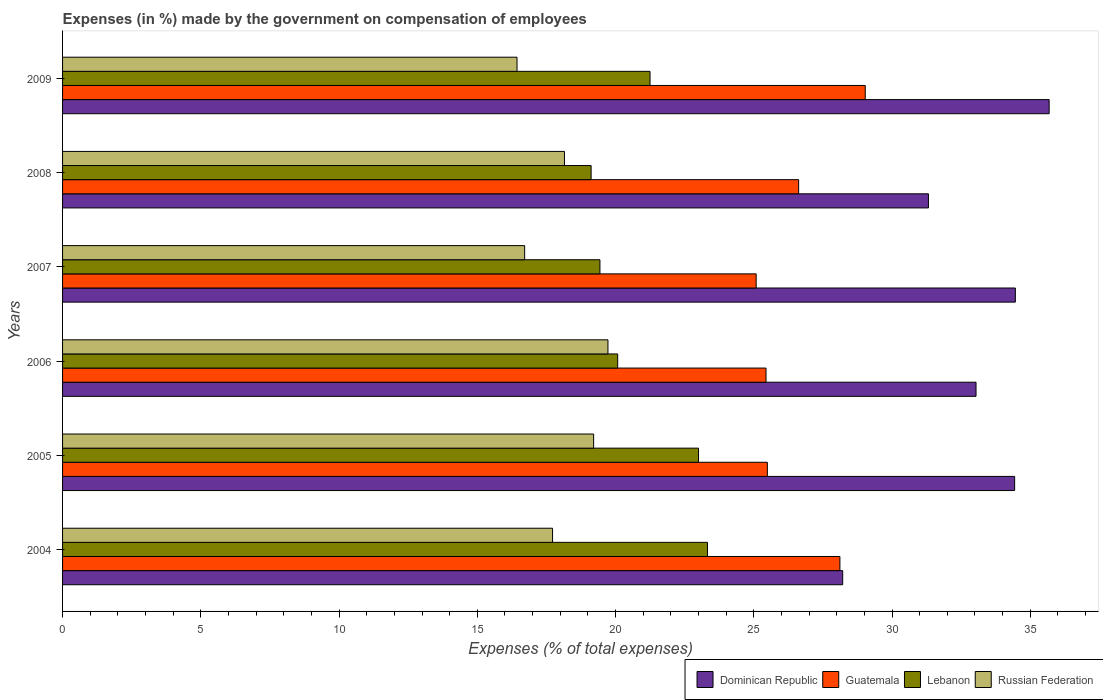Are the number of bars per tick equal to the number of legend labels?
Your answer should be very brief. Yes. What is the label of the 2nd group of bars from the top?
Provide a succinct answer. 2008. In how many cases, is the number of bars for a given year not equal to the number of legend labels?
Provide a short and direct response. 0. What is the percentage of expenses made by the government on compensation of employees in Dominican Republic in 2004?
Ensure brevity in your answer.  28.22. Across all years, what is the maximum percentage of expenses made by the government on compensation of employees in Guatemala?
Provide a succinct answer. 29.03. Across all years, what is the minimum percentage of expenses made by the government on compensation of employees in Dominican Republic?
Offer a very short reply. 28.22. What is the total percentage of expenses made by the government on compensation of employees in Dominican Republic in the graph?
Offer a terse response. 197.15. What is the difference between the percentage of expenses made by the government on compensation of employees in Dominican Republic in 2006 and that in 2008?
Ensure brevity in your answer.  1.72. What is the difference between the percentage of expenses made by the government on compensation of employees in Lebanon in 2006 and the percentage of expenses made by the government on compensation of employees in Guatemala in 2005?
Your response must be concise. -5.41. What is the average percentage of expenses made by the government on compensation of employees in Russian Federation per year?
Give a very brief answer. 17.99. In the year 2006, what is the difference between the percentage of expenses made by the government on compensation of employees in Russian Federation and percentage of expenses made by the government on compensation of employees in Guatemala?
Keep it short and to the point. -5.72. What is the ratio of the percentage of expenses made by the government on compensation of employees in Dominican Republic in 2004 to that in 2005?
Provide a short and direct response. 0.82. Is the difference between the percentage of expenses made by the government on compensation of employees in Russian Federation in 2004 and 2007 greater than the difference between the percentage of expenses made by the government on compensation of employees in Guatemala in 2004 and 2007?
Give a very brief answer. No. What is the difference between the highest and the second highest percentage of expenses made by the government on compensation of employees in Lebanon?
Your answer should be very brief. 0.32. What is the difference between the highest and the lowest percentage of expenses made by the government on compensation of employees in Dominican Republic?
Offer a very short reply. 7.47. In how many years, is the percentage of expenses made by the government on compensation of employees in Lebanon greater than the average percentage of expenses made by the government on compensation of employees in Lebanon taken over all years?
Provide a short and direct response. 3. Is it the case that in every year, the sum of the percentage of expenses made by the government on compensation of employees in Russian Federation and percentage of expenses made by the government on compensation of employees in Guatemala is greater than the sum of percentage of expenses made by the government on compensation of employees in Dominican Republic and percentage of expenses made by the government on compensation of employees in Lebanon?
Make the answer very short. No. What does the 2nd bar from the top in 2007 represents?
Provide a succinct answer. Lebanon. What does the 2nd bar from the bottom in 2009 represents?
Ensure brevity in your answer.  Guatemala. How many bars are there?
Keep it short and to the point. 24. Are all the bars in the graph horizontal?
Your answer should be compact. Yes. What is the difference between two consecutive major ticks on the X-axis?
Ensure brevity in your answer.  5. Are the values on the major ticks of X-axis written in scientific E-notation?
Your answer should be compact. No. Does the graph contain grids?
Give a very brief answer. No. What is the title of the graph?
Provide a short and direct response. Expenses (in %) made by the government on compensation of employees. Does "Andorra" appear as one of the legend labels in the graph?
Provide a succinct answer. No. What is the label or title of the X-axis?
Your answer should be compact. Expenses (% of total expenses). What is the label or title of the Y-axis?
Provide a succinct answer. Years. What is the Expenses (% of total expenses) in Dominican Republic in 2004?
Your answer should be very brief. 28.22. What is the Expenses (% of total expenses) in Guatemala in 2004?
Offer a very short reply. 28.12. What is the Expenses (% of total expenses) of Lebanon in 2004?
Provide a succinct answer. 23.33. What is the Expenses (% of total expenses) of Russian Federation in 2004?
Give a very brief answer. 17.72. What is the Expenses (% of total expenses) of Dominican Republic in 2005?
Provide a short and direct response. 34.43. What is the Expenses (% of total expenses) of Guatemala in 2005?
Give a very brief answer. 25.49. What is the Expenses (% of total expenses) in Lebanon in 2005?
Your answer should be compact. 23. What is the Expenses (% of total expenses) in Russian Federation in 2005?
Offer a terse response. 19.21. What is the Expenses (% of total expenses) in Dominican Republic in 2006?
Your response must be concise. 33.04. What is the Expenses (% of total expenses) of Guatemala in 2006?
Give a very brief answer. 25.44. What is the Expenses (% of total expenses) of Lebanon in 2006?
Provide a short and direct response. 20.08. What is the Expenses (% of total expenses) of Russian Federation in 2006?
Provide a succinct answer. 19.73. What is the Expenses (% of total expenses) in Dominican Republic in 2007?
Provide a succinct answer. 34.46. What is the Expenses (% of total expenses) of Guatemala in 2007?
Give a very brief answer. 25.09. What is the Expenses (% of total expenses) in Lebanon in 2007?
Your response must be concise. 19.44. What is the Expenses (% of total expenses) in Russian Federation in 2007?
Provide a succinct answer. 16.71. What is the Expenses (% of total expenses) of Dominican Republic in 2008?
Your answer should be compact. 31.32. What is the Expenses (% of total expenses) of Guatemala in 2008?
Offer a terse response. 26.62. What is the Expenses (% of total expenses) of Lebanon in 2008?
Make the answer very short. 19.12. What is the Expenses (% of total expenses) of Russian Federation in 2008?
Give a very brief answer. 18.15. What is the Expenses (% of total expenses) in Dominican Republic in 2009?
Make the answer very short. 35.68. What is the Expenses (% of total expenses) in Guatemala in 2009?
Your answer should be very brief. 29.03. What is the Expenses (% of total expenses) of Lebanon in 2009?
Offer a terse response. 21.25. What is the Expenses (% of total expenses) in Russian Federation in 2009?
Your answer should be compact. 16.44. Across all years, what is the maximum Expenses (% of total expenses) in Dominican Republic?
Your answer should be compact. 35.68. Across all years, what is the maximum Expenses (% of total expenses) of Guatemala?
Your answer should be compact. 29.03. Across all years, what is the maximum Expenses (% of total expenses) in Lebanon?
Offer a terse response. 23.33. Across all years, what is the maximum Expenses (% of total expenses) in Russian Federation?
Offer a terse response. 19.73. Across all years, what is the minimum Expenses (% of total expenses) in Dominican Republic?
Provide a succinct answer. 28.22. Across all years, what is the minimum Expenses (% of total expenses) of Guatemala?
Provide a short and direct response. 25.09. Across all years, what is the minimum Expenses (% of total expenses) in Lebanon?
Your answer should be compact. 19.12. Across all years, what is the minimum Expenses (% of total expenses) in Russian Federation?
Give a very brief answer. 16.44. What is the total Expenses (% of total expenses) in Dominican Republic in the graph?
Provide a succinct answer. 197.15. What is the total Expenses (% of total expenses) of Guatemala in the graph?
Provide a short and direct response. 159.79. What is the total Expenses (% of total expenses) of Lebanon in the graph?
Ensure brevity in your answer.  126.2. What is the total Expenses (% of total expenses) in Russian Federation in the graph?
Provide a short and direct response. 107.96. What is the difference between the Expenses (% of total expenses) in Dominican Republic in 2004 and that in 2005?
Provide a succinct answer. -6.22. What is the difference between the Expenses (% of total expenses) in Guatemala in 2004 and that in 2005?
Offer a terse response. 2.62. What is the difference between the Expenses (% of total expenses) of Lebanon in 2004 and that in 2005?
Your answer should be very brief. 0.32. What is the difference between the Expenses (% of total expenses) in Russian Federation in 2004 and that in 2005?
Make the answer very short. -1.49. What is the difference between the Expenses (% of total expenses) in Dominican Republic in 2004 and that in 2006?
Provide a succinct answer. -4.82. What is the difference between the Expenses (% of total expenses) of Guatemala in 2004 and that in 2006?
Offer a very short reply. 2.67. What is the difference between the Expenses (% of total expenses) of Lebanon in 2004 and that in 2006?
Give a very brief answer. 3.25. What is the difference between the Expenses (% of total expenses) in Russian Federation in 2004 and that in 2006?
Offer a terse response. -2. What is the difference between the Expenses (% of total expenses) of Dominican Republic in 2004 and that in 2007?
Keep it short and to the point. -6.25. What is the difference between the Expenses (% of total expenses) of Guatemala in 2004 and that in 2007?
Your answer should be very brief. 3.03. What is the difference between the Expenses (% of total expenses) in Lebanon in 2004 and that in 2007?
Ensure brevity in your answer.  3.89. What is the difference between the Expenses (% of total expenses) of Russian Federation in 2004 and that in 2007?
Make the answer very short. 1.01. What is the difference between the Expenses (% of total expenses) of Dominican Republic in 2004 and that in 2008?
Give a very brief answer. -3.1. What is the difference between the Expenses (% of total expenses) of Guatemala in 2004 and that in 2008?
Your response must be concise. 1.49. What is the difference between the Expenses (% of total expenses) in Lebanon in 2004 and that in 2008?
Offer a very short reply. 4.21. What is the difference between the Expenses (% of total expenses) of Russian Federation in 2004 and that in 2008?
Offer a terse response. -0.43. What is the difference between the Expenses (% of total expenses) in Dominican Republic in 2004 and that in 2009?
Make the answer very short. -7.47. What is the difference between the Expenses (% of total expenses) of Guatemala in 2004 and that in 2009?
Keep it short and to the point. -0.92. What is the difference between the Expenses (% of total expenses) in Lebanon in 2004 and that in 2009?
Provide a succinct answer. 2.08. What is the difference between the Expenses (% of total expenses) of Russian Federation in 2004 and that in 2009?
Ensure brevity in your answer.  1.29. What is the difference between the Expenses (% of total expenses) of Dominican Republic in 2005 and that in 2006?
Your answer should be very brief. 1.4. What is the difference between the Expenses (% of total expenses) of Guatemala in 2005 and that in 2006?
Your answer should be compact. 0.05. What is the difference between the Expenses (% of total expenses) of Lebanon in 2005 and that in 2006?
Keep it short and to the point. 2.92. What is the difference between the Expenses (% of total expenses) of Russian Federation in 2005 and that in 2006?
Your response must be concise. -0.52. What is the difference between the Expenses (% of total expenses) in Dominican Republic in 2005 and that in 2007?
Your response must be concise. -0.03. What is the difference between the Expenses (% of total expenses) of Guatemala in 2005 and that in 2007?
Your answer should be very brief. 0.41. What is the difference between the Expenses (% of total expenses) of Lebanon in 2005 and that in 2007?
Make the answer very short. 3.57. What is the difference between the Expenses (% of total expenses) in Russian Federation in 2005 and that in 2007?
Give a very brief answer. 2.49. What is the difference between the Expenses (% of total expenses) in Dominican Republic in 2005 and that in 2008?
Offer a terse response. 3.12. What is the difference between the Expenses (% of total expenses) in Guatemala in 2005 and that in 2008?
Your answer should be very brief. -1.13. What is the difference between the Expenses (% of total expenses) of Lebanon in 2005 and that in 2008?
Give a very brief answer. 3.88. What is the difference between the Expenses (% of total expenses) of Russian Federation in 2005 and that in 2008?
Your answer should be very brief. 1.05. What is the difference between the Expenses (% of total expenses) in Dominican Republic in 2005 and that in 2009?
Make the answer very short. -1.25. What is the difference between the Expenses (% of total expenses) in Guatemala in 2005 and that in 2009?
Make the answer very short. -3.54. What is the difference between the Expenses (% of total expenses) in Lebanon in 2005 and that in 2009?
Offer a terse response. 1.75. What is the difference between the Expenses (% of total expenses) in Russian Federation in 2005 and that in 2009?
Your answer should be very brief. 2.77. What is the difference between the Expenses (% of total expenses) of Dominican Republic in 2006 and that in 2007?
Keep it short and to the point. -1.42. What is the difference between the Expenses (% of total expenses) in Guatemala in 2006 and that in 2007?
Keep it short and to the point. 0.36. What is the difference between the Expenses (% of total expenses) in Lebanon in 2006 and that in 2007?
Ensure brevity in your answer.  0.64. What is the difference between the Expenses (% of total expenses) in Russian Federation in 2006 and that in 2007?
Ensure brevity in your answer.  3.01. What is the difference between the Expenses (% of total expenses) in Dominican Republic in 2006 and that in 2008?
Offer a very short reply. 1.72. What is the difference between the Expenses (% of total expenses) in Guatemala in 2006 and that in 2008?
Offer a very short reply. -1.18. What is the difference between the Expenses (% of total expenses) in Russian Federation in 2006 and that in 2008?
Your answer should be compact. 1.57. What is the difference between the Expenses (% of total expenses) of Dominican Republic in 2006 and that in 2009?
Give a very brief answer. -2.65. What is the difference between the Expenses (% of total expenses) in Guatemala in 2006 and that in 2009?
Your answer should be very brief. -3.59. What is the difference between the Expenses (% of total expenses) in Lebanon in 2006 and that in 2009?
Your answer should be very brief. -1.17. What is the difference between the Expenses (% of total expenses) of Russian Federation in 2006 and that in 2009?
Offer a very short reply. 3.29. What is the difference between the Expenses (% of total expenses) of Dominican Republic in 2007 and that in 2008?
Provide a short and direct response. 3.14. What is the difference between the Expenses (% of total expenses) of Guatemala in 2007 and that in 2008?
Your answer should be very brief. -1.54. What is the difference between the Expenses (% of total expenses) in Lebanon in 2007 and that in 2008?
Your answer should be compact. 0.32. What is the difference between the Expenses (% of total expenses) of Russian Federation in 2007 and that in 2008?
Make the answer very short. -1.44. What is the difference between the Expenses (% of total expenses) of Dominican Republic in 2007 and that in 2009?
Ensure brevity in your answer.  -1.22. What is the difference between the Expenses (% of total expenses) of Guatemala in 2007 and that in 2009?
Offer a terse response. -3.95. What is the difference between the Expenses (% of total expenses) in Lebanon in 2007 and that in 2009?
Provide a succinct answer. -1.81. What is the difference between the Expenses (% of total expenses) of Russian Federation in 2007 and that in 2009?
Provide a short and direct response. 0.28. What is the difference between the Expenses (% of total expenses) in Dominican Republic in 2008 and that in 2009?
Make the answer very short. -4.37. What is the difference between the Expenses (% of total expenses) in Guatemala in 2008 and that in 2009?
Make the answer very short. -2.41. What is the difference between the Expenses (% of total expenses) of Lebanon in 2008 and that in 2009?
Provide a short and direct response. -2.13. What is the difference between the Expenses (% of total expenses) in Russian Federation in 2008 and that in 2009?
Make the answer very short. 1.72. What is the difference between the Expenses (% of total expenses) in Dominican Republic in 2004 and the Expenses (% of total expenses) in Guatemala in 2005?
Your answer should be compact. 2.72. What is the difference between the Expenses (% of total expenses) of Dominican Republic in 2004 and the Expenses (% of total expenses) of Lebanon in 2005?
Keep it short and to the point. 5.21. What is the difference between the Expenses (% of total expenses) of Dominican Republic in 2004 and the Expenses (% of total expenses) of Russian Federation in 2005?
Give a very brief answer. 9.01. What is the difference between the Expenses (% of total expenses) of Guatemala in 2004 and the Expenses (% of total expenses) of Lebanon in 2005?
Keep it short and to the point. 5.11. What is the difference between the Expenses (% of total expenses) in Guatemala in 2004 and the Expenses (% of total expenses) in Russian Federation in 2005?
Offer a very short reply. 8.91. What is the difference between the Expenses (% of total expenses) in Lebanon in 2004 and the Expenses (% of total expenses) in Russian Federation in 2005?
Keep it short and to the point. 4.12. What is the difference between the Expenses (% of total expenses) in Dominican Republic in 2004 and the Expenses (% of total expenses) in Guatemala in 2006?
Provide a short and direct response. 2.77. What is the difference between the Expenses (% of total expenses) in Dominican Republic in 2004 and the Expenses (% of total expenses) in Lebanon in 2006?
Offer a terse response. 8.14. What is the difference between the Expenses (% of total expenses) of Dominican Republic in 2004 and the Expenses (% of total expenses) of Russian Federation in 2006?
Provide a succinct answer. 8.49. What is the difference between the Expenses (% of total expenses) of Guatemala in 2004 and the Expenses (% of total expenses) of Lebanon in 2006?
Your answer should be very brief. 8.04. What is the difference between the Expenses (% of total expenses) of Guatemala in 2004 and the Expenses (% of total expenses) of Russian Federation in 2006?
Make the answer very short. 8.39. What is the difference between the Expenses (% of total expenses) of Lebanon in 2004 and the Expenses (% of total expenses) of Russian Federation in 2006?
Your response must be concise. 3.6. What is the difference between the Expenses (% of total expenses) in Dominican Republic in 2004 and the Expenses (% of total expenses) in Guatemala in 2007?
Ensure brevity in your answer.  3.13. What is the difference between the Expenses (% of total expenses) of Dominican Republic in 2004 and the Expenses (% of total expenses) of Lebanon in 2007?
Your response must be concise. 8.78. What is the difference between the Expenses (% of total expenses) in Dominican Republic in 2004 and the Expenses (% of total expenses) in Russian Federation in 2007?
Your answer should be compact. 11.5. What is the difference between the Expenses (% of total expenses) of Guatemala in 2004 and the Expenses (% of total expenses) of Lebanon in 2007?
Make the answer very short. 8.68. What is the difference between the Expenses (% of total expenses) in Guatemala in 2004 and the Expenses (% of total expenses) in Russian Federation in 2007?
Your answer should be compact. 11.4. What is the difference between the Expenses (% of total expenses) of Lebanon in 2004 and the Expenses (% of total expenses) of Russian Federation in 2007?
Keep it short and to the point. 6.61. What is the difference between the Expenses (% of total expenses) of Dominican Republic in 2004 and the Expenses (% of total expenses) of Guatemala in 2008?
Provide a succinct answer. 1.59. What is the difference between the Expenses (% of total expenses) of Dominican Republic in 2004 and the Expenses (% of total expenses) of Lebanon in 2008?
Offer a very short reply. 9.1. What is the difference between the Expenses (% of total expenses) in Dominican Republic in 2004 and the Expenses (% of total expenses) in Russian Federation in 2008?
Ensure brevity in your answer.  10.06. What is the difference between the Expenses (% of total expenses) of Guatemala in 2004 and the Expenses (% of total expenses) of Lebanon in 2008?
Your answer should be compact. 9. What is the difference between the Expenses (% of total expenses) in Guatemala in 2004 and the Expenses (% of total expenses) in Russian Federation in 2008?
Your answer should be very brief. 9.96. What is the difference between the Expenses (% of total expenses) of Lebanon in 2004 and the Expenses (% of total expenses) of Russian Federation in 2008?
Offer a very short reply. 5.17. What is the difference between the Expenses (% of total expenses) in Dominican Republic in 2004 and the Expenses (% of total expenses) in Guatemala in 2009?
Make the answer very short. -0.82. What is the difference between the Expenses (% of total expenses) of Dominican Republic in 2004 and the Expenses (% of total expenses) of Lebanon in 2009?
Offer a very short reply. 6.97. What is the difference between the Expenses (% of total expenses) in Dominican Republic in 2004 and the Expenses (% of total expenses) in Russian Federation in 2009?
Your answer should be compact. 11.78. What is the difference between the Expenses (% of total expenses) in Guatemala in 2004 and the Expenses (% of total expenses) in Lebanon in 2009?
Your answer should be compact. 6.87. What is the difference between the Expenses (% of total expenses) of Guatemala in 2004 and the Expenses (% of total expenses) of Russian Federation in 2009?
Offer a terse response. 11.68. What is the difference between the Expenses (% of total expenses) of Lebanon in 2004 and the Expenses (% of total expenses) of Russian Federation in 2009?
Your response must be concise. 6.89. What is the difference between the Expenses (% of total expenses) of Dominican Republic in 2005 and the Expenses (% of total expenses) of Guatemala in 2006?
Ensure brevity in your answer.  8.99. What is the difference between the Expenses (% of total expenses) of Dominican Republic in 2005 and the Expenses (% of total expenses) of Lebanon in 2006?
Provide a short and direct response. 14.36. What is the difference between the Expenses (% of total expenses) of Dominican Republic in 2005 and the Expenses (% of total expenses) of Russian Federation in 2006?
Your answer should be very brief. 14.71. What is the difference between the Expenses (% of total expenses) in Guatemala in 2005 and the Expenses (% of total expenses) in Lebanon in 2006?
Ensure brevity in your answer.  5.41. What is the difference between the Expenses (% of total expenses) of Guatemala in 2005 and the Expenses (% of total expenses) of Russian Federation in 2006?
Make the answer very short. 5.77. What is the difference between the Expenses (% of total expenses) in Lebanon in 2005 and the Expenses (% of total expenses) in Russian Federation in 2006?
Give a very brief answer. 3.28. What is the difference between the Expenses (% of total expenses) of Dominican Republic in 2005 and the Expenses (% of total expenses) of Guatemala in 2007?
Offer a very short reply. 9.35. What is the difference between the Expenses (% of total expenses) of Dominican Republic in 2005 and the Expenses (% of total expenses) of Lebanon in 2007?
Keep it short and to the point. 15. What is the difference between the Expenses (% of total expenses) of Dominican Republic in 2005 and the Expenses (% of total expenses) of Russian Federation in 2007?
Keep it short and to the point. 17.72. What is the difference between the Expenses (% of total expenses) of Guatemala in 2005 and the Expenses (% of total expenses) of Lebanon in 2007?
Ensure brevity in your answer.  6.06. What is the difference between the Expenses (% of total expenses) in Guatemala in 2005 and the Expenses (% of total expenses) in Russian Federation in 2007?
Give a very brief answer. 8.78. What is the difference between the Expenses (% of total expenses) in Lebanon in 2005 and the Expenses (% of total expenses) in Russian Federation in 2007?
Ensure brevity in your answer.  6.29. What is the difference between the Expenses (% of total expenses) in Dominican Republic in 2005 and the Expenses (% of total expenses) in Guatemala in 2008?
Ensure brevity in your answer.  7.81. What is the difference between the Expenses (% of total expenses) in Dominican Republic in 2005 and the Expenses (% of total expenses) in Lebanon in 2008?
Your answer should be very brief. 15.32. What is the difference between the Expenses (% of total expenses) in Dominican Republic in 2005 and the Expenses (% of total expenses) in Russian Federation in 2008?
Provide a short and direct response. 16.28. What is the difference between the Expenses (% of total expenses) in Guatemala in 2005 and the Expenses (% of total expenses) in Lebanon in 2008?
Your response must be concise. 6.37. What is the difference between the Expenses (% of total expenses) in Guatemala in 2005 and the Expenses (% of total expenses) in Russian Federation in 2008?
Your answer should be very brief. 7.34. What is the difference between the Expenses (% of total expenses) in Lebanon in 2005 and the Expenses (% of total expenses) in Russian Federation in 2008?
Offer a very short reply. 4.85. What is the difference between the Expenses (% of total expenses) of Dominican Republic in 2005 and the Expenses (% of total expenses) of Guatemala in 2009?
Offer a very short reply. 5.4. What is the difference between the Expenses (% of total expenses) in Dominican Republic in 2005 and the Expenses (% of total expenses) in Lebanon in 2009?
Your response must be concise. 13.19. What is the difference between the Expenses (% of total expenses) of Dominican Republic in 2005 and the Expenses (% of total expenses) of Russian Federation in 2009?
Give a very brief answer. 18. What is the difference between the Expenses (% of total expenses) in Guatemala in 2005 and the Expenses (% of total expenses) in Lebanon in 2009?
Give a very brief answer. 4.24. What is the difference between the Expenses (% of total expenses) in Guatemala in 2005 and the Expenses (% of total expenses) in Russian Federation in 2009?
Give a very brief answer. 9.05. What is the difference between the Expenses (% of total expenses) of Lebanon in 2005 and the Expenses (% of total expenses) of Russian Federation in 2009?
Keep it short and to the point. 6.56. What is the difference between the Expenses (% of total expenses) of Dominican Republic in 2006 and the Expenses (% of total expenses) of Guatemala in 2007?
Ensure brevity in your answer.  7.95. What is the difference between the Expenses (% of total expenses) of Dominican Republic in 2006 and the Expenses (% of total expenses) of Lebanon in 2007?
Your answer should be compact. 13.6. What is the difference between the Expenses (% of total expenses) in Dominican Republic in 2006 and the Expenses (% of total expenses) in Russian Federation in 2007?
Give a very brief answer. 16.33. What is the difference between the Expenses (% of total expenses) of Guatemala in 2006 and the Expenses (% of total expenses) of Lebanon in 2007?
Offer a very short reply. 6.01. What is the difference between the Expenses (% of total expenses) of Guatemala in 2006 and the Expenses (% of total expenses) of Russian Federation in 2007?
Offer a terse response. 8.73. What is the difference between the Expenses (% of total expenses) of Lebanon in 2006 and the Expenses (% of total expenses) of Russian Federation in 2007?
Offer a terse response. 3.36. What is the difference between the Expenses (% of total expenses) of Dominican Republic in 2006 and the Expenses (% of total expenses) of Guatemala in 2008?
Offer a terse response. 6.42. What is the difference between the Expenses (% of total expenses) in Dominican Republic in 2006 and the Expenses (% of total expenses) in Lebanon in 2008?
Offer a terse response. 13.92. What is the difference between the Expenses (% of total expenses) in Dominican Republic in 2006 and the Expenses (% of total expenses) in Russian Federation in 2008?
Make the answer very short. 14.89. What is the difference between the Expenses (% of total expenses) of Guatemala in 2006 and the Expenses (% of total expenses) of Lebanon in 2008?
Your response must be concise. 6.33. What is the difference between the Expenses (% of total expenses) in Guatemala in 2006 and the Expenses (% of total expenses) in Russian Federation in 2008?
Provide a succinct answer. 7.29. What is the difference between the Expenses (% of total expenses) in Lebanon in 2006 and the Expenses (% of total expenses) in Russian Federation in 2008?
Your answer should be compact. 1.92. What is the difference between the Expenses (% of total expenses) in Dominican Republic in 2006 and the Expenses (% of total expenses) in Guatemala in 2009?
Give a very brief answer. 4.01. What is the difference between the Expenses (% of total expenses) of Dominican Republic in 2006 and the Expenses (% of total expenses) of Lebanon in 2009?
Offer a terse response. 11.79. What is the difference between the Expenses (% of total expenses) in Dominican Republic in 2006 and the Expenses (% of total expenses) in Russian Federation in 2009?
Your answer should be compact. 16.6. What is the difference between the Expenses (% of total expenses) in Guatemala in 2006 and the Expenses (% of total expenses) in Lebanon in 2009?
Ensure brevity in your answer.  4.2. What is the difference between the Expenses (% of total expenses) of Guatemala in 2006 and the Expenses (% of total expenses) of Russian Federation in 2009?
Ensure brevity in your answer.  9.01. What is the difference between the Expenses (% of total expenses) in Lebanon in 2006 and the Expenses (% of total expenses) in Russian Federation in 2009?
Provide a succinct answer. 3.64. What is the difference between the Expenses (% of total expenses) of Dominican Republic in 2007 and the Expenses (% of total expenses) of Guatemala in 2008?
Your response must be concise. 7.84. What is the difference between the Expenses (% of total expenses) of Dominican Republic in 2007 and the Expenses (% of total expenses) of Lebanon in 2008?
Your answer should be very brief. 15.34. What is the difference between the Expenses (% of total expenses) of Dominican Republic in 2007 and the Expenses (% of total expenses) of Russian Federation in 2008?
Provide a succinct answer. 16.31. What is the difference between the Expenses (% of total expenses) of Guatemala in 2007 and the Expenses (% of total expenses) of Lebanon in 2008?
Give a very brief answer. 5.97. What is the difference between the Expenses (% of total expenses) of Guatemala in 2007 and the Expenses (% of total expenses) of Russian Federation in 2008?
Make the answer very short. 6.93. What is the difference between the Expenses (% of total expenses) in Lebanon in 2007 and the Expenses (% of total expenses) in Russian Federation in 2008?
Offer a very short reply. 1.28. What is the difference between the Expenses (% of total expenses) of Dominican Republic in 2007 and the Expenses (% of total expenses) of Guatemala in 2009?
Keep it short and to the point. 5.43. What is the difference between the Expenses (% of total expenses) in Dominican Republic in 2007 and the Expenses (% of total expenses) in Lebanon in 2009?
Your answer should be compact. 13.21. What is the difference between the Expenses (% of total expenses) of Dominican Republic in 2007 and the Expenses (% of total expenses) of Russian Federation in 2009?
Your response must be concise. 18.02. What is the difference between the Expenses (% of total expenses) of Guatemala in 2007 and the Expenses (% of total expenses) of Lebanon in 2009?
Your answer should be very brief. 3.84. What is the difference between the Expenses (% of total expenses) in Guatemala in 2007 and the Expenses (% of total expenses) in Russian Federation in 2009?
Your response must be concise. 8.65. What is the difference between the Expenses (% of total expenses) in Lebanon in 2007 and the Expenses (% of total expenses) in Russian Federation in 2009?
Ensure brevity in your answer.  3. What is the difference between the Expenses (% of total expenses) in Dominican Republic in 2008 and the Expenses (% of total expenses) in Guatemala in 2009?
Offer a very short reply. 2.28. What is the difference between the Expenses (% of total expenses) of Dominican Republic in 2008 and the Expenses (% of total expenses) of Lebanon in 2009?
Provide a succinct answer. 10.07. What is the difference between the Expenses (% of total expenses) in Dominican Republic in 2008 and the Expenses (% of total expenses) in Russian Federation in 2009?
Your answer should be very brief. 14.88. What is the difference between the Expenses (% of total expenses) of Guatemala in 2008 and the Expenses (% of total expenses) of Lebanon in 2009?
Your response must be concise. 5.38. What is the difference between the Expenses (% of total expenses) of Guatemala in 2008 and the Expenses (% of total expenses) of Russian Federation in 2009?
Provide a succinct answer. 10.19. What is the difference between the Expenses (% of total expenses) in Lebanon in 2008 and the Expenses (% of total expenses) in Russian Federation in 2009?
Your answer should be very brief. 2.68. What is the average Expenses (% of total expenses) of Dominican Republic per year?
Offer a terse response. 32.86. What is the average Expenses (% of total expenses) in Guatemala per year?
Provide a succinct answer. 26.63. What is the average Expenses (% of total expenses) of Lebanon per year?
Give a very brief answer. 21.03. What is the average Expenses (% of total expenses) in Russian Federation per year?
Offer a very short reply. 17.99. In the year 2004, what is the difference between the Expenses (% of total expenses) of Dominican Republic and Expenses (% of total expenses) of Guatemala?
Your response must be concise. 0.1. In the year 2004, what is the difference between the Expenses (% of total expenses) of Dominican Republic and Expenses (% of total expenses) of Lebanon?
Your answer should be compact. 4.89. In the year 2004, what is the difference between the Expenses (% of total expenses) in Dominican Republic and Expenses (% of total expenses) in Russian Federation?
Ensure brevity in your answer.  10.49. In the year 2004, what is the difference between the Expenses (% of total expenses) of Guatemala and Expenses (% of total expenses) of Lebanon?
Provide a succinct answer. 4.79. In the year 2004, what is the difference between the Expenses (% of total expenses) of Guatemala and Expenses (% of total expenses) of Russian Federation?
Your answer should be very brief. 10.39. In the year 2004, what is the difference between the Expenses (% of total expenses) of Lebanon and Expenses (% of total expenses) of Russian Federation?
Provide a succinct answer. 5.6. In the year 2005, what is the difference between the Expenses (% of total expenses) in Dominican Republic and Expenses (% of total expenses) in Guatemala?
Offer a terse response. 8.94. In the year 2005, what is the difference between the Expenses (% of total expenses) in Dominican Republic and Expenses (% of total expenses) in Lebanon?
Make the answer very short. 11.43. In the year 2005, what is the difference between the Expenses (% of total expenses) in Dominican Republic and Expenses (% of total expenses) in Russian Federation?
Your answer should be very brief. 15.23. In the year 2005, what is the difference between the Expenses (% of total expenses) in Guatemala and Expenses (% of total expenses) in Lebanon?
Offer a very short reply. 2.49. In the year 2005, what is the difference between the Expenses (% of total expenses) in Guatemala and Expenses (% of total expenses) in Russian Federation?
Your response must be concise. 6.28. In the year 2005, what is the difference between the Expenses (% of total expenses) in Lebanon and Expenses (% of total expenses) in Russian Federation?
Ensure brevity in your answer.  3.79. In the year 2006, what is the difference between the Expenses (% of total expenses) in Dominican Republic and Expenses (% of total expenses) in Guatemala?
Give a very brief answer. 7.6. In the year 2006, what is the difference between the Expenses (% of total expenses) of Dominican Republic and Expenses (% of total expenses) of Lebanon?
Ensure brevity in your answer.  12.96. In the year 2006, what is the difference between the Expenses (% of total expenses) of Dominican Republic and Expenses (% of total expenses) of Russian Federation?
Provide a short and direct response. 13.31. In the year 2006, what is the difference between the Expenses (% of total expenses) of Guatemala and Expenses (% of total expenses) of Lebanon?
Provide a succinct answer. 5.37. In the year 2006, what is the difference between the Expenses (% of total expenses) in Guatemala and Expenses (% of total expenses) in Russian Federation?
Keep it short and to the point. 5.72. In the year 2006, what is the difference between the Expenses (% of total expenses) in Lebanon and Expenses (% of total expenses) in Russian Federation?
Your answer should be compact. 0.35. In the year 2007, what is the difference between the Expenses (% of total expenses) in Dominican Republic and Expenses (% of total expenses) in Guatemala?
Offer a very short reply. 9.38. In the year 2007, what is the difference between the Expenses (% of total expenses) in Dominican Republic and Expenses (% of total expenses) in Lebanon?
Your response must be concise. 15.03. In the year 2007, what is the difference between the Expenses (% of total expenses) of Dominican Republic and Expenses (% of total expenses) of Russian Federation?
Provide a short and direct response. 17.75. In the year 2007, what is the difference between the Expenses (% of total expenses) in Guatemala and Expenses (% of total expenses) in Lebanon?
Your answer should be very brief. 5.65. In the year 2007, what is the difference between the Expenses (% of total expenses) in Guatemala and Expenses (% of total expenses) in Russian Federation?
Ensure brevity in your answer.  8.37. In the year 2007, what is the difference between the Expenses (% of total expenses) of Lebanon and Expenses (% of total expenses) of Russian Federation?
Your response must be concise. 2.72. In the year 2008, what is the difference between the Expenses (% of total expenses) in Dominican Republic and Expenses (% of total expenses) in Guatemala?
Give a very brief answer. 4.69. In the year 2008, what is the difference between the Expenses (% of total expenses) of Dominican Republic and Expenses (% of total expenses) of Lebanon?
Your answer should be very brief. 12.2. In the year 2008, what is the difference between the Expenses (% of total expenses) in Dominican Republic and Expenses (% of total expenses) in Russian Federation?
Make the answer very short. 13.16. In the year 2008, what is the difference between the Expenses (% of total expenses) of Guatemala and Expenses (% of total expenses) of Lebanon?
Give a very brief answer. 7.51. In the year 2008, what is the difference between the Expenses (% of total expenses) of Guatemala and Expenses (% of total expenses) of Russian Federation?
Offer a very short reply. 8.47. In the year 2008, what is the difference between the Expenses (% of total expenses) in Lebanon and Expenses (% of total expenses) in Russian Federation?
Offer a terse response. 0.96. In the year 2009, what is the difference between the Expenses (% of total expenses) of Dominican Republic and Expenses (% of total expenses) of Guatemala?
Keep it short and to the point. 6.65. In the year 2009, what is the difference between the Expenses (% of total expenses) of Dominican Republic and Expenses (% of total expenses) of Lebanon?
Provide a succinct answer. 14.44. In the year 2009, what is the difference between the Expenses (% of total expenses) in Dominican Republic and Expenses (% of total expenses) in Russian Federation?
Your answer should be compact. 19.25. In the year 2009, what is the difference between the Expenses (% of total expenses) in Guatemala and Expenses (% of total expenses) in Lebanon?
Provide a succinct answer. 7.78. In the year 2009, what is the difference between the Expenses (% of total expenses) of Guatemala and Expenses (% of total expenses) of Russian Federation?
Your answer should be compact. 12.6. In the year 2009, what is the difference between the Expenses (% of total expenses) in Lebanon and Expenses (% of total expenses) in Russian Federation?
Make the answer very short. 4.81. What is the ratio of the Expenses (% of total expenses) in Dominican Republic in 2004 to that in 2005?
Your answer should be compact. 0.82. What is the ratio of the Expenses (% of total expenses) of Guatemala in 2004 to that in 2005?
Give a very brief answer. 1.1. What is the ratio of the Expenses (% of total expenses) in Lebanon in 2004 to that in 2005?
Your answer should be compact. 1.01. What is the ratio of the Expenses (% of total expenses) in Russian Federation in 2004 to that in 2005?
Keep it short and to the point. 0.92. What is the ratio of the Expenses (% of total expenses) in Dominican Republic in 2004 to that in 2006?
Your answer should be compact. 0.85. What is the ratio of the Expenses (% of total expenses) in Guatemala in 2004 to that in 2006?
Offer a terse response. 1.1. What is the ratio of the Expenses (% of total expenses) of Lebanon in 2004 to that in 2006?
Provide a short and direct response. 1.16. What is the ratio of the Expenses (% of total expenses) of Russian Federation in 2004 to that in 2006?
Give a very brief answer. 0.9. What is the ratio of the Expenses (% of total expenses) in Dominican Republic in 2004 to that in 2007?
Keep it short and to the point. 0.82. What is the ratio of the Expenses (% of total expenses) in Guatemala in 2004 to that in 2007?
Your answer should be compact. 1.12. What is the ratio of the Expenses (% of total expenses) of Lebanon in 2004 to that in 2007?
Provide a succinct answer. 1.2. What is the ratio of the Expenses (% of total expenses) of Russian Federation in 2004 to that in 2007?
Your response must be concise. 1.06. What is the ratio of the Expenses (% of total expenses) of Dominican Republic in 2004 to that in 2008?
Keep it short and to the point. 0.9. What is the ratio of the Expenses (% of total expenses) in Guatemala in 2004 to that in 2008?
Your answer should be compact. 1.06. What is the ratio of the Expenses (% of total expenses) in Lebanon in 2004 to that in 2008?
Ensure brevity in your answer.  1.22. What is the ratio of the Expenses (% of total expenses) of Russian Federation in 2004 to that in 2008?
Offer a very short reply. 0.98. What is the ratio of the Expenses (% of total expenses) in Dominican Republic in 2004 to that in 2009?
Your response must be concise. 0.79. What is the ratio of the Expenses (% of total expenses) of Guatemala in 2004 to that in 2009?
Provide a succinct answer. 0.97. What is the ratio of the Expenses (% of total expenses) of Lebanon in 2004 to that in 2009?
Make the answer very short. 1.1. What is the ratio of the Expenses (% of total expenses) in Russian Federation in 2004 to that in 2009?
Provide a succinct answer. 1.08. What is the ratio of the Expenses (% of total expenses) in Dominican Republic in 2005 to that in 2006?
Give a very brief answer. 1.04. What is the ratio of the Expenses (% of total expenses) of Guatemala in 2005 to that in 2006?
Offer a very short reply. 1. What is the ratio of the Expenses (% of total expenses) of Lebanon in 2005 to that in 2006?
Your answer should be very brief. 1.15. What is the ratio of the Expenses (% of total expenses) of Russian Federation in 2005 to that in 2006?
Provide a short and direct response. 0.97. What is the ratio of the Expenses (% of total expenses) in Guatemala in 2005 to that in 2007?
Ensure brevity in your answer.  1.02. What is the ratio of the Expenses (% of total expenses) of Lebanon in 2005 to that in 2007?
Offer a very short reply. 1.18. What is the ratio of the Expenses (% of total expenses) in Russian Federation in 2005 to that in 2007?
Provide a succinct answer. 1.15. What is the ratio of the Expenses (% of total expenses) in Dominican Republic in 2005 to that in 2008?
Your response must be concise. 1.1. What is the ratio of the Expenses (% of total expenses) of Guatemala in 2005 to that in 2008?
Your answer should be very brief. 0.96. What is the ratio of the Expenses (% of total expenses) of Lebanon in 2005 to that in 2008?
Make the answer very short. 1.2. What is the ratio of the Expenses (% of total expenses) of Russian Federation in 2005 to that in 2008?
Offer a terse response. 1.06. What is the ratio of the Expenses (% of total expenses) of Guatemala in 2005 to that in 2009?
Offer a very short reply. 0.88. What is the ratio of the Expenses (% of total expenses) in Lebanon in 2005 to that in 2009?
Offer a very short reply. 1.08. What is the ratio of the Expenses (% of total expenses) in Russian Federation in 2005 to that in 2009?
Provide a succinct answer. 1.17. What is the ratio of the Expenses (% of total expenses) of Dominican Republic in 2006 to that in 2007?
Make the answer very short. 0.96. What is the ratio of the Expenses (% of total expenses) in Guatemala in 2006 to that in 2007?
Ensure brevity in your answer.  1.01. What is the ratio of the Expenses (% of total expenses) of Lebanon in 2006 to that in 2007?
Your answer should be compact. 1.03. What is the ratio of the Expenses (% of total expenses) in Russian Federation in 2006 to that in 2007?
Provide a short and direct response. 1.18. What is the ratio of the Expenses (% of total expenses) in Dominican Republic in 2006 to that in 2008?
Make the answer very short. 1.05. What is the ratio of the Expenses (% of total expenses) of Guatemala in 2006 to that in 2008?
Ensure brevity in your answer.  0.96. What is the ratio of the Expenses (% of total expenses) in Lebanon in 2006 to that in 2008?
Keep it short and to the point. 1.05. What is the ratio of the Expenses (% of total expenses) in Russian Federation in 2006 to that in 2008?
Offer a terse response. 1.09. What is the ratio of the Expenses (% of total expenses) in Dominican Republic in 2006 to that in 2009?
Your response must be concise. 0.93. What is the ratio of the Expenses (% of total expenses) of Guatemala in 2006 to that in 2009?
Your answer should be very brief. 0.88. What is the ratio of the Expenses (% of total expenses) in Lebanon in 2006 to that in 2009?
Offer a very short reply. 0.94. What is the ratio of the Expenses (% of total expenses) in Russian Federation in 2006 to that in 2009?
Ensure brevity in your answer.  1.2. What is the ratio of the Expenses (% of total expenses) of Dominican Republic in 2007 to that in 2008?
Provide a succinct answer. 1.1. What is the ratio of the Expenses (% of total expenses) of Guatemala in 2007 to that in 2008?
Your answer should be compact. 0.94. What is the ratio of the Expenses (% of total expenses) in Lebanon in 2007 to that in 2008?
Keep it short and to the point. 1.02. What is the ratio of the Expenses (% of total expenses) of Russian Federation in 2007 to that in 2008?
Offer a terse response. 0.92. What is the ratio of the Expenses (% of total expenses) in Dominican Republic in 2007 to that in 2009?
Offer a very short reply. 0.97. What is the ratio of the Expenses (% of total expenses) in Guatemala in 2007 to that in 2009?
Give a very brief answer. 0.86. What is the ratio of the Expenses (% of total expenses) in Lebanon in 2007 to that in 2009?
Your answer should be compact. 0.91. What is the ratio of the Expenses (% of total expenses) of Russian Federation in 2007 to that in 2009?
Provide a short and direct response. 1.02. What is the ratio of the Expenses (% of total expenses) in Dominican Republic in 2008 to that in 2009?
Make the answer very short. 0.88. What is the ratio of the Expenses (% of total expenses) in Guatemala in 2008 to that in 2009?
Provide a short and direct response. 0.92. What is the ratio of the Expenses (% of total expenses) of Lebanon in 2008 to that in 2009?
Your response must be concise. 0.9. What is the ratio of the Expenses (% of total expenses) in Russian Federation in 2008 to that in 2009?
Offer a terse response. 1.1. What is the difference between the highest and the second highest Expenses (% of total expenses) of Dominican Republic?
Keep it short and to the point. 1.22. What is the difference between the highest and the second highest Expenses (% of total expenses) in Guatemala?
Your answer should be compact. 0.92. What is the difference between the highest and the second highest Expenses (% of total expenses) in Lebanon?
Your answer should be compact. 0.32. What is the difference between the highest and the second highest Expenses (% of total expenses) of Russian Federation?
Provide a short and direct response. 0.52. What is the difference between the highest and the lowest Expenses (% of total expenses) in Dominican Republic?
Your answer should be compact. 7.47. What is the difference between the highest and the lowest Expenses (% of total expenses) of Guatemala?
Your answer should be very brief. 3.95. What is the difference between the highest and the lowest Expenses (% of total expenses) in Lebanon?
Keep it short and to the point. 4.21. What is the difference between the highest and the lowest Expenses (% of total expenses) in Russian Federation?
Your response must be concise. 3.29. 